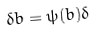Convert formula to latex. <formula><loc_0><loc_0><loc_500><loc_500>\delta b = \psi ( b ) \delta</formula> 